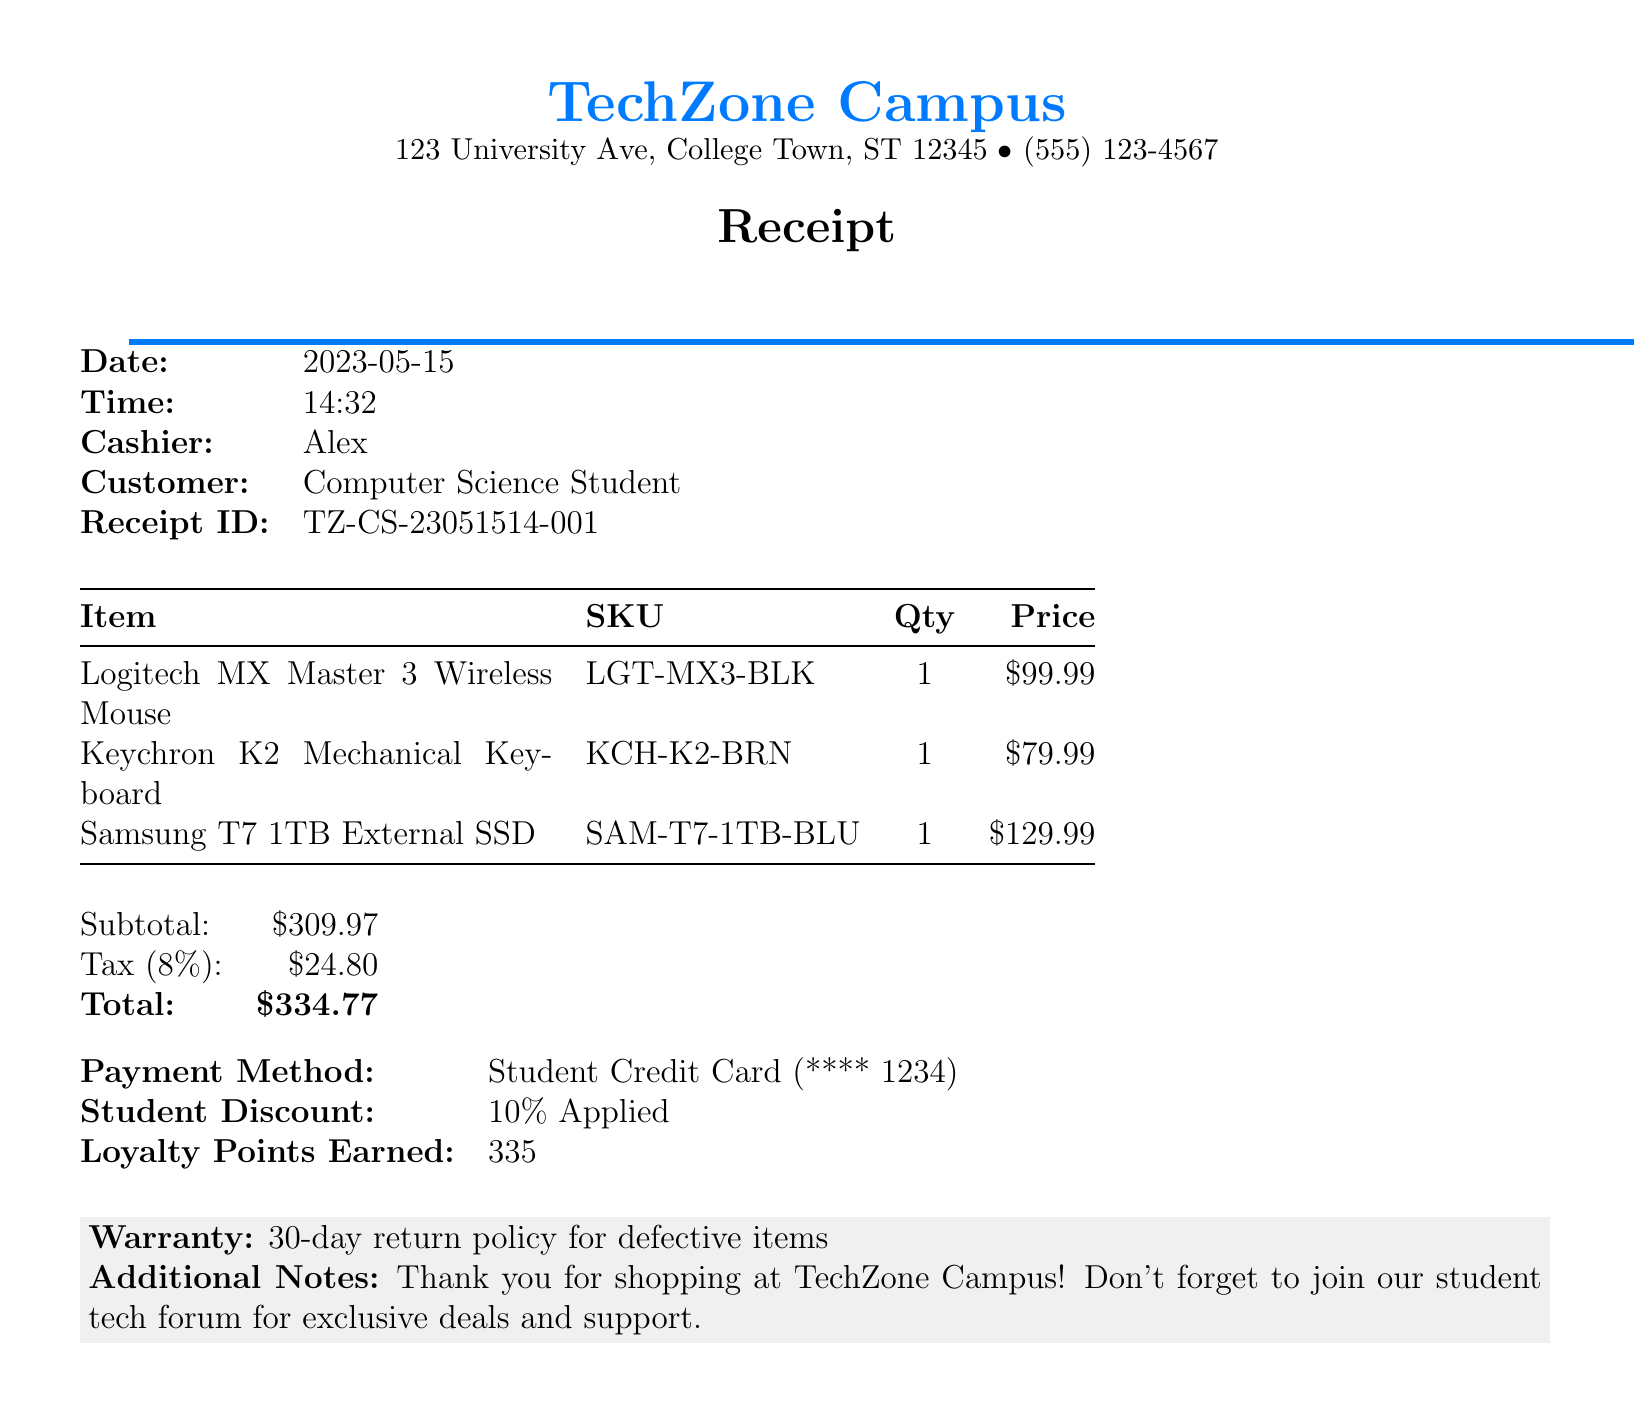What is the store name? The store name is mentioned in the document's header.
Answer: TechZone Campus What is the address of the store? The address includes the street and city details listed in the document.
Answer: 123 University Ave, College Town, ST 12345 Who was the cashier? The cashier's name is stated in the receipts details.
Answer: Alex What was the price of the external hard drive? The price is specified next to the item in the list of purchases.
Answer: $129.99 What is the tax rate applied? The document states the tax rate as a percentage.
Answer: 8% How much loyalty points were earned? The loyalty points earned are clearly indicated in the document.
Answer: 335 What discount was applied to the purchase? The receipt specifies the discount offered to the customer.
Answer: 10% Applied What is the total amount spent? The total is summarized at the end of the receipt.
Answer: $334.77 What is the warranty policy? The warranty information is included towards the end of the document.
Answer: 30-day return policy for defective items 